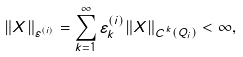Convert formula to latex. <formula><loc_0><loc_0><loc_500><loc_500>\| X \| _ { \varepsilon ^ { ( i ) } } = \sum ^ { \infty } _ { k = 1 } \varepsilon _ { k } ^ { ( i ) } \| X \| _ { C ^ { k } ( Q _ { i } ) } < \infty ,</formula> 